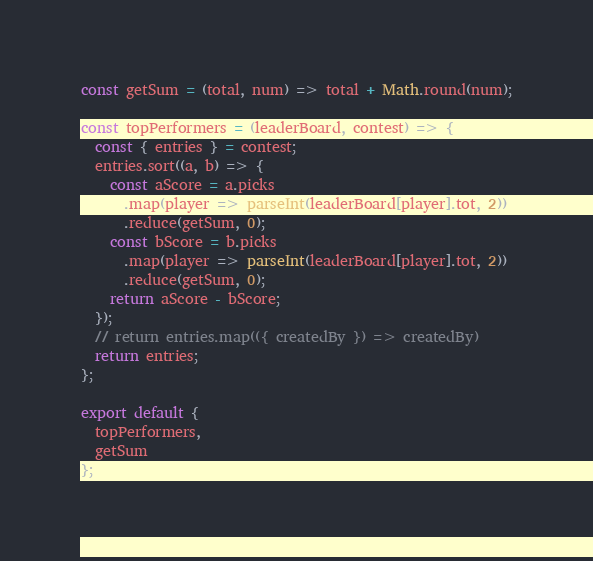<code> <loc_0><loc_0><loc_500><loc_500><_JavaScript_>const getSum = (total, num) => total + Math.round(num);

const topPerformers = (leaderBoard, contest) => {
  const { entries } = contest;
  entries.sort((a, b) => {
    const aScore = a.picks
      .map(player => parseInt(leaderBoard[player].tot, 2))
      .reduce(getSum, 0);
    const bScore = b.picks
      .map(player => parseInt(leaderBoard[player].tot, 2))
      .reduce(getSum, 0);
    return aScore - bScore;
  });
  // return entries.map(({ createdBy }) => createdBy)
  return entries;
};

export default {
  topPerformers,
  getSum
};
</code> 